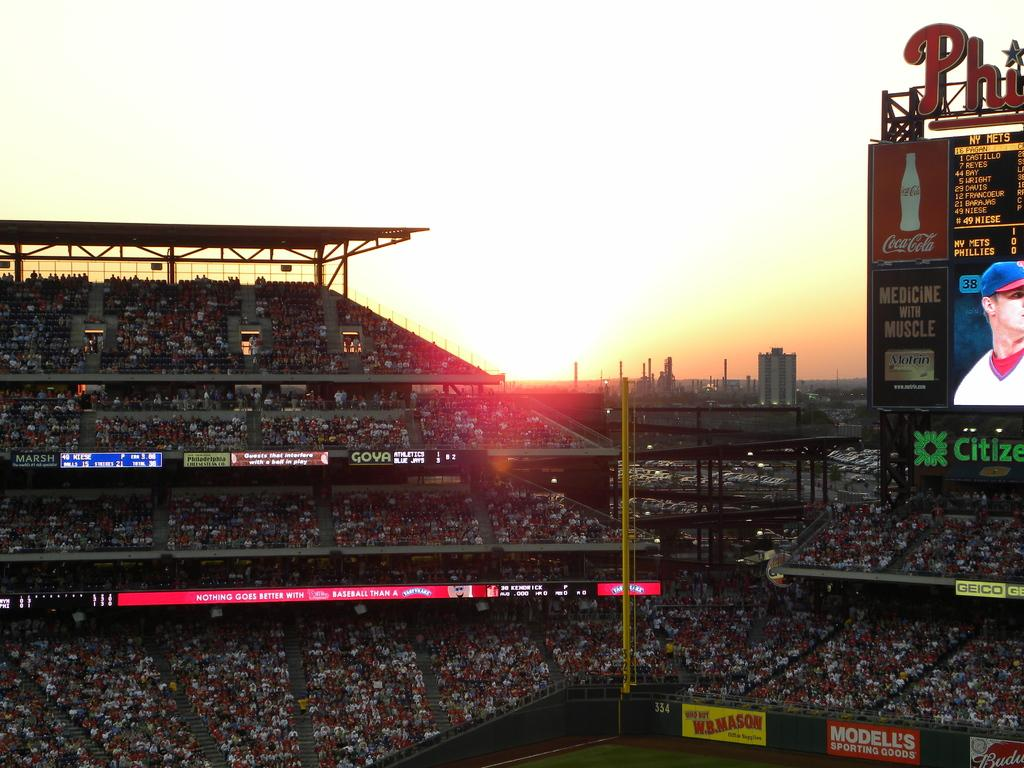<image>
Create a compact narrative representing the image presented. The packed stadium over left field at the Phillies stadium. 